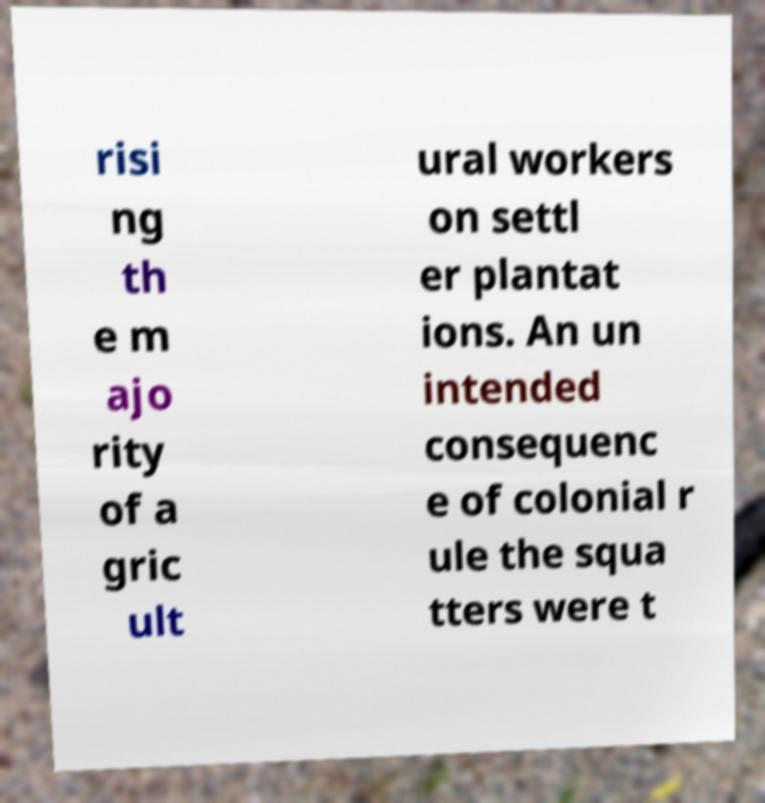Could you extract and type out the text from this image? risi ng th e m ajo rity of a gric ult ural workers on settl er plantat ions. An un intended consequenc e of colonial r ule the squa tters were t 